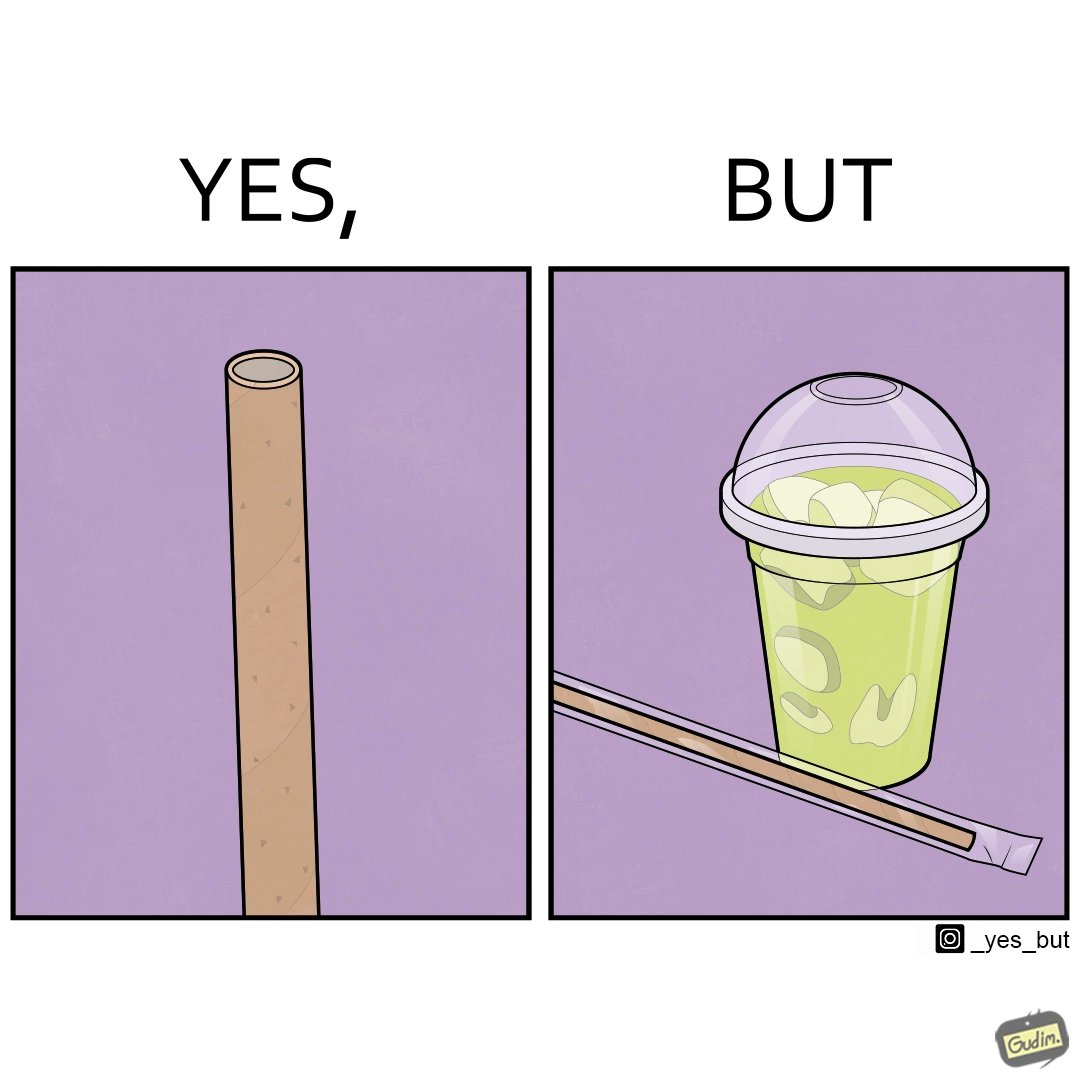Does this image contain satire or humor? Yes, this image is satirical. 